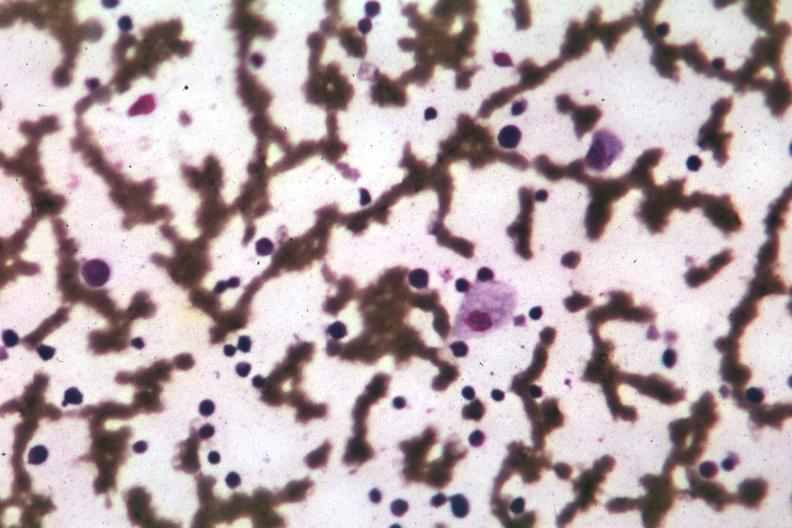does carcinomatosis show wrights single cell easily seen?
Answer the question using a single word or phrase. No 